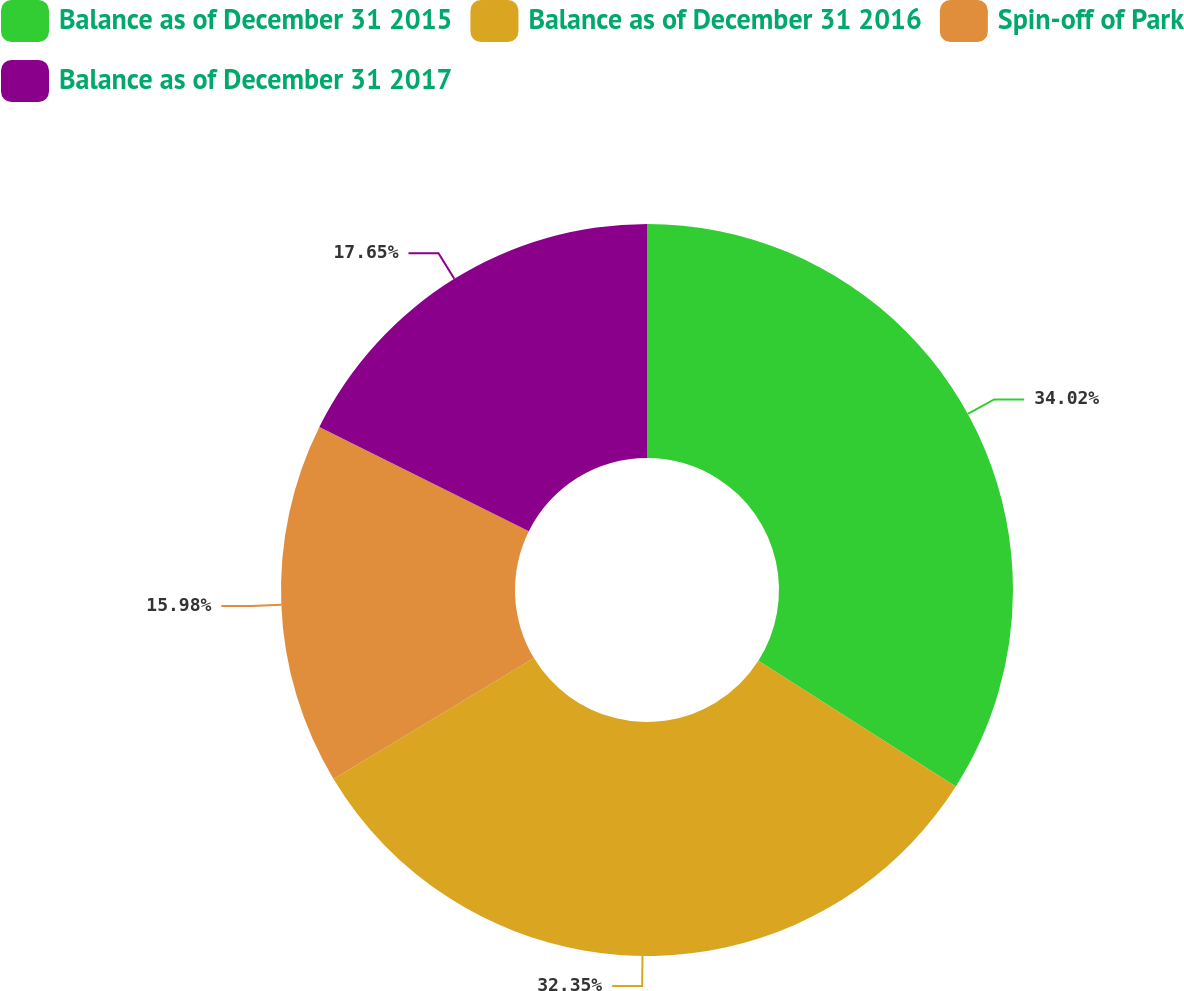<chart> <loc_0><loc_0><loc_500><loc_500><pie_chart><fcel>Balance as of December 31 2015<fcel>Balance as of December 31 2016<fcel>Spin-off of Park<fcel>Balance as of December 31 2017<nl><fcel>34.02%<fcel>32.35%<fcel>15.98%<fcel>17.65%<nl></chart> 